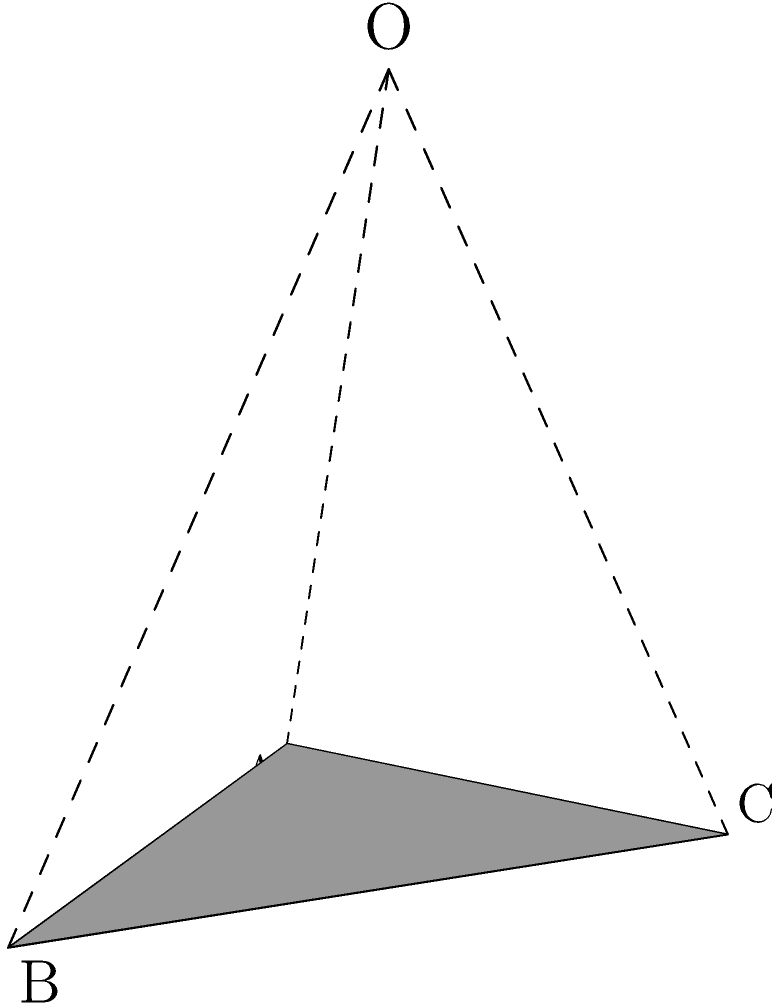As the supportive dean of a film program, you're helping the director visualize a new spotlight for the studio. The spotlight is modeled as a cone with a circular base. The base has a radius of 1 unit, and the height of the cone is 3 units. What is the volume of this spotlight? To find the volume of the cone-shaped spotlight, we'll follow these steps:

1. Recall the formula for the volume of a cone:
   $$V = \frac{1}{3}\pi r^2 h$$
   where $V$ is the volume, $r$ is the radius of the base, and $h$ is the height of the cone.

2. We're given:
   - Radius ($r$) = 1 unit
   - Height ($h$) = 3 units

3. Let's substitute these values into the formula:
   $$V = \frac{1}{3}\pi (1)^2 (3)$$

4. Simplify:
   $$V = \frac{1}{3}\pi \cdot 1 \cdot 3 = \pi$$

5. Therefore, the volume of the spotlight is $\pi$ cubic units.
Answer: $\pi$ cubic units 